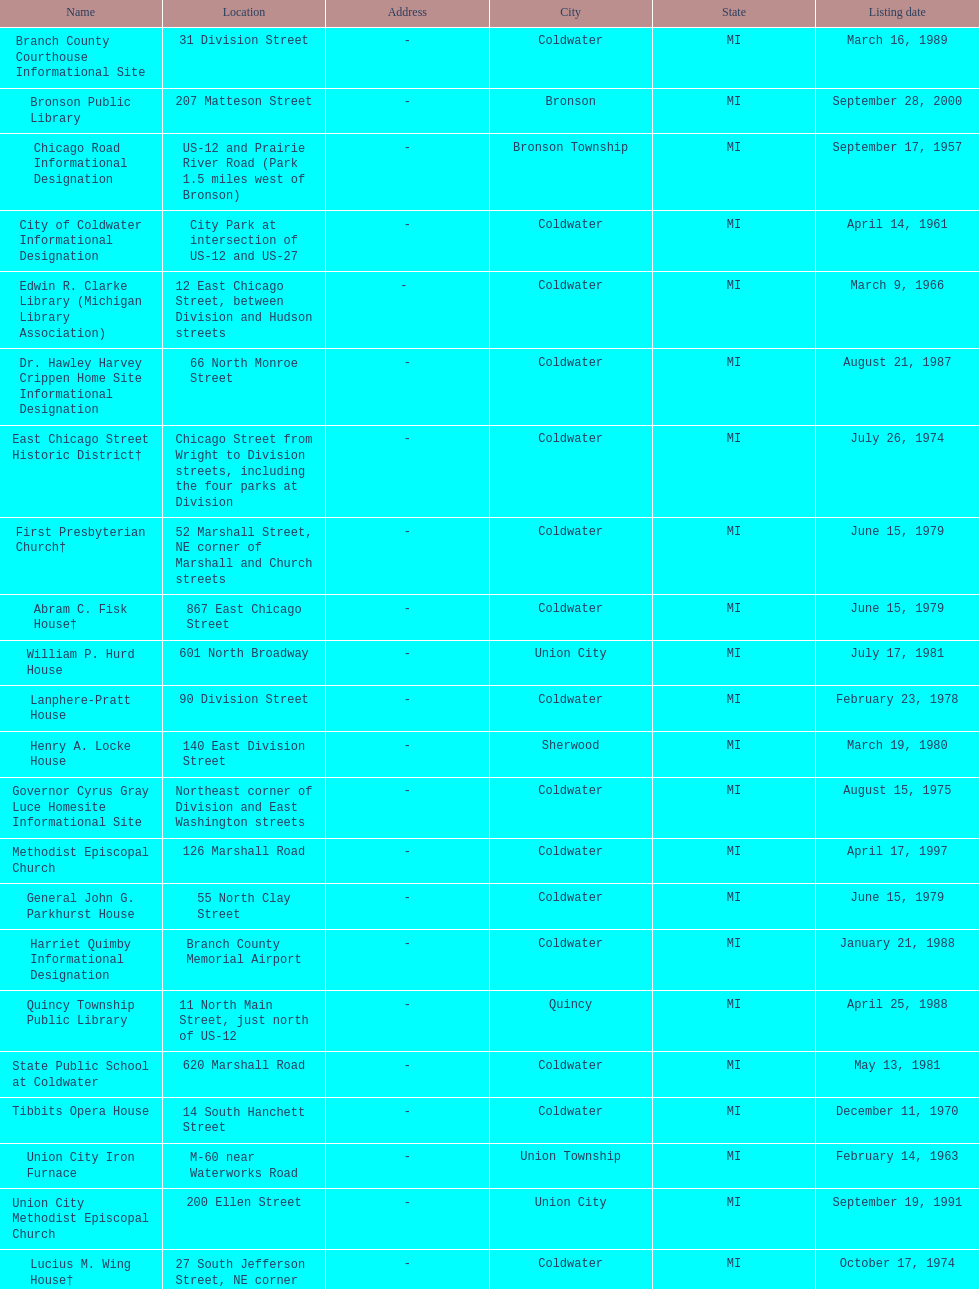What is the name for the exclusive listing date on april 14, 1961? City of Coldwater. 